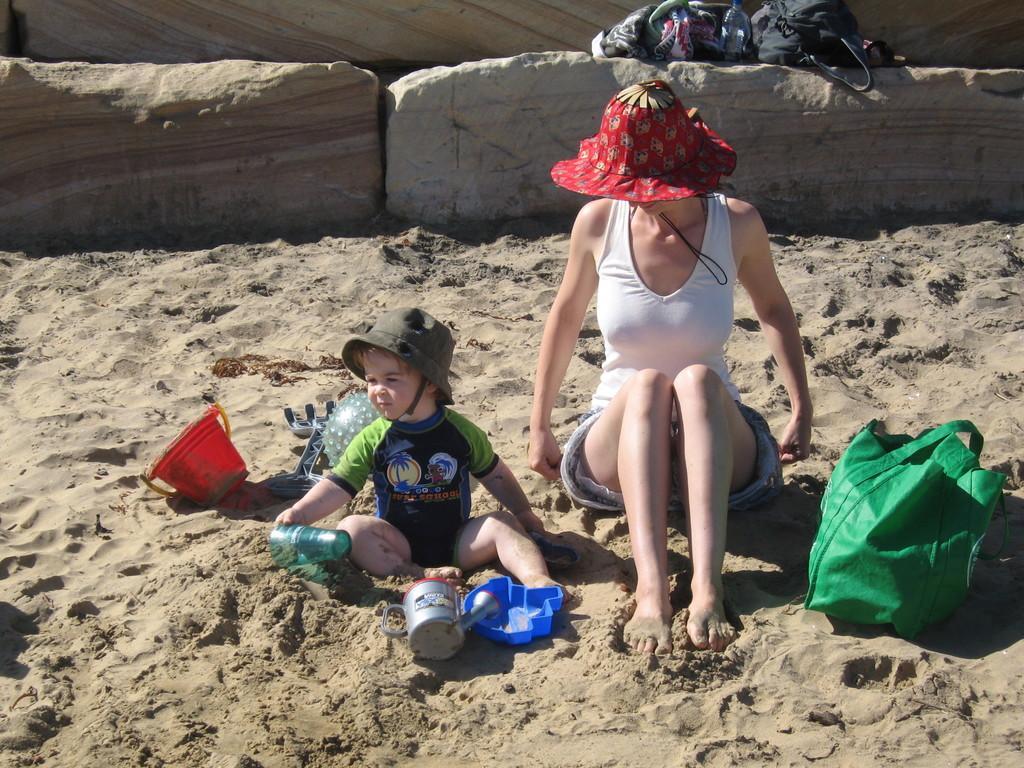Could you give a brief overview of what you see in this image? In the picture I can see a child and woman wearing white color dress and hat are sitting on the sand, here I can see a bucket, few objects and a green color bag placed on the sand. In the background, I can see stones upon which bags are kept. 